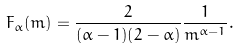Convert formula to latex. <formula><loc_0><loc_0><loc_500><loc_500>F _ { \alpha } ( m ) = \frac { 2 } { ( \alpha - 1 ) ( 2 - \alpha ) } \frac { 1 } { m ^ { \alpha - 1 } } .</formula> 